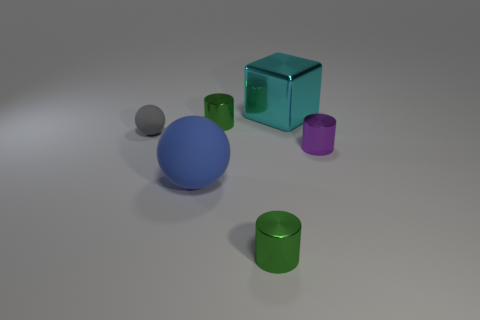Is the large object that is in front of the gray rubber object made of the same material as the purple cylinder?
Provide a short and direct response. No. How many other things are made of the same material as the purple thing?
Give a very brief answer. 3. How many things are either small metallic things to the right of the big cyan block or rubber things on the right side of the gray rubber sphere?
Make the answer very short. 2. There is a small metal object that is on the right side of the big metallic cube; does it have the same shape as the small green metallic object that is behind the big rubber ball?
Provide a short and direct response. Yes. The rubber thing that is the same size as the cyan metal block is what shape?
Give a very brief answer. Sphere. How many metal things are tiny cyan cylinders or large blue things?
Give a very brief answer. 0. Is the material of the big thing behind the small ball the same as the tiny thing that is in front of the large blue object?
Make the answer very short. Yes. There is a object that is the same material as the big sphere; what is its color?
Ensure brevity in your answer.  Gray. Is the number of spheres behind the small gray matte thing greater than the number of shiny cylinders that are on the left side of the small purple cylinder?
Keep it short and to the point. No. Is there a small purple metal cylinder?
Your response must be concise. Yes. 